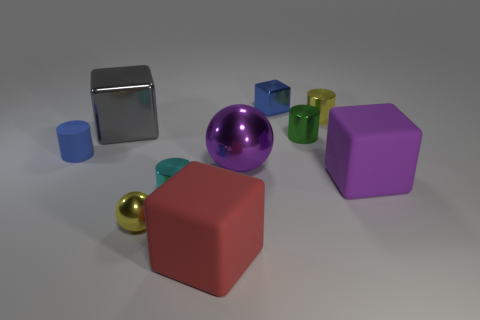How do the colors of the objects contribute to the aesthetics of this image? The image showcases a variety of vibrant colors that create a visually appealing composition. The purple hue of the metal sphere and the largest cube add a touch of elegance and harmony, as purple is often associated with royalty and creativity. The other blocks and cylinders include blue, green, red, and yellow, which introduce a sense of playfulness and diversity, capturing the viewer's attention and evoking a cheerful mood. The subtle interplay of colors makes the scene look dynamic yet balanced. 